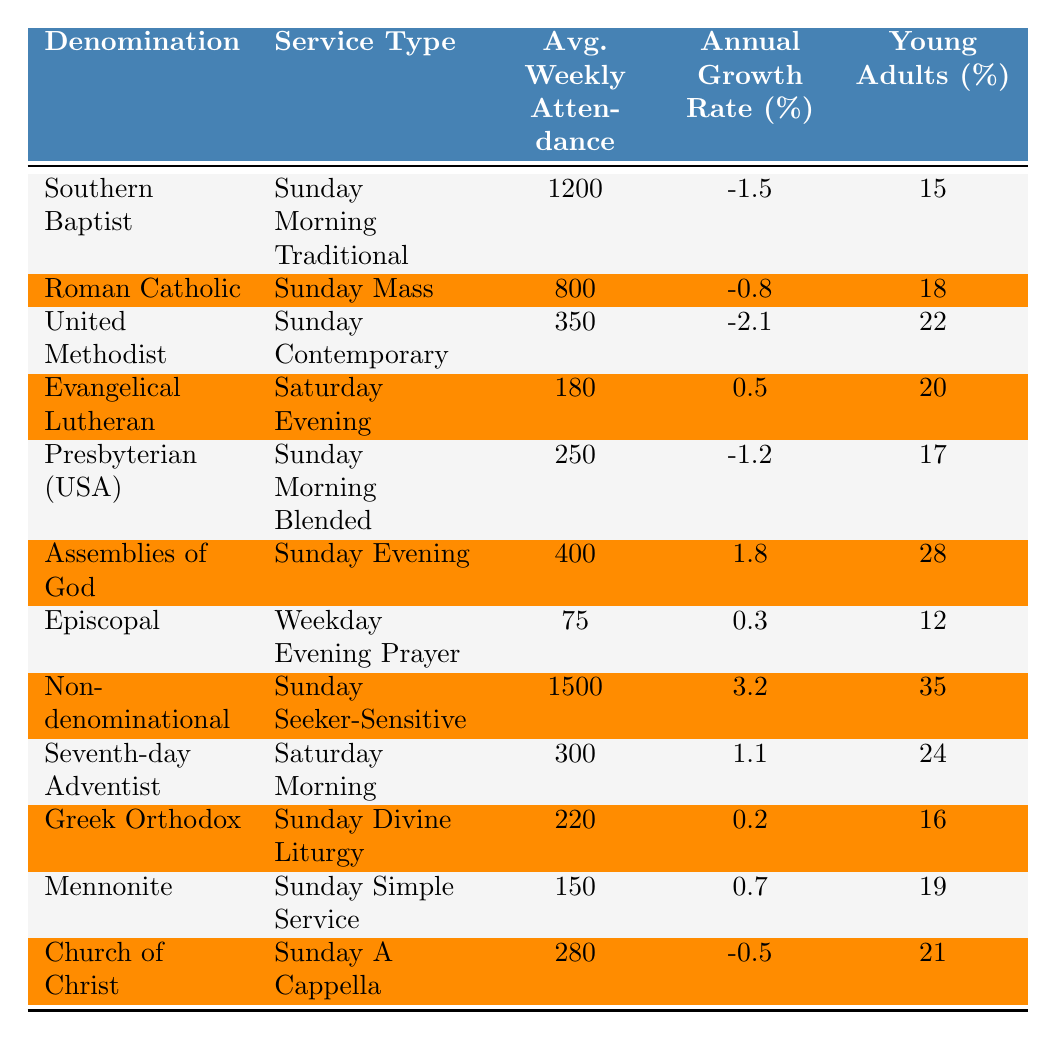What denomination has the highest average weekly attendance? By examining the "Average Weekly Attendance" column, the Non-denominational service type has the highest figure listed at 1500.
Answer: Non-denominational Which service type has the lowest average weekly attendance? Looking at the "Average Weekly Attendance" column, the service type with the lowest attendance is "Weekday Evening Prayer," with an attendance of 75.
Answer: Weekday Evening Prayer What is the annual growth rate of the United Methodist Church's Sunday Contemporary service? The annual growth rate for the United Methodist Church's Sunday Contemporary service is directly listed as -2.1%.
Answer: -2.1% What is the total average weekly attendance for all service types in the table? To find the total, we sum the average weekly attendance values: 1200 + 800 + 350 + 180 + 250 + 400 + 75 + 1500 + 300 + 220 + 150 + 280 = 4055.
Answer: 4055 Which service has the highest percentage of young adults (ages 18-29)? The table shows that the Non-denominational service type has the highest percentage of young adults at 35%.
Answer: 35% Is the annual growth rate for Assemblies of God’s Sunday Evening service positive or negative? The annual growth rate for Assemblies of God’s Sunday Evening service is listed as 1.8%, indicating it is positive.
Answer: Yes How many denominations have a negative annual growth rate? By counting the entries with negative annual growth rates, we find 5 denominations: Southern Baptist, Roman Catholic, United Methodist, Presbyterian (USA), and Church of Christ.
Answer: 5 What is the average attendance of services that have an annual growth rate over 1%? We only consider the services with growth rates over 1%, which are Non-denominational (1500), Assemblies of God (400), and Seventh-day Adventist (300). Their average is (1500 + 400 + 300) / 3 = 733.33.
Answer: 733.33 Which denomination has a higher percentage of young adults: Assemblies of God or Presbyterian (USA)? Assemblies of God has a young adult percentage of 28%, whereas Presbyterian (USA) has 17%. Therefore, Assemblies of God has a higher percentage of young adults.
Answer: Assemblies of God What is the difference in average weekly attendance between Southern Baptist and Roman Catholic services? Southern Baptist has an average attendance of 1200, while Roman Catholic has 800. The difference is 1200 - 800 = 400.
Answer: 400 